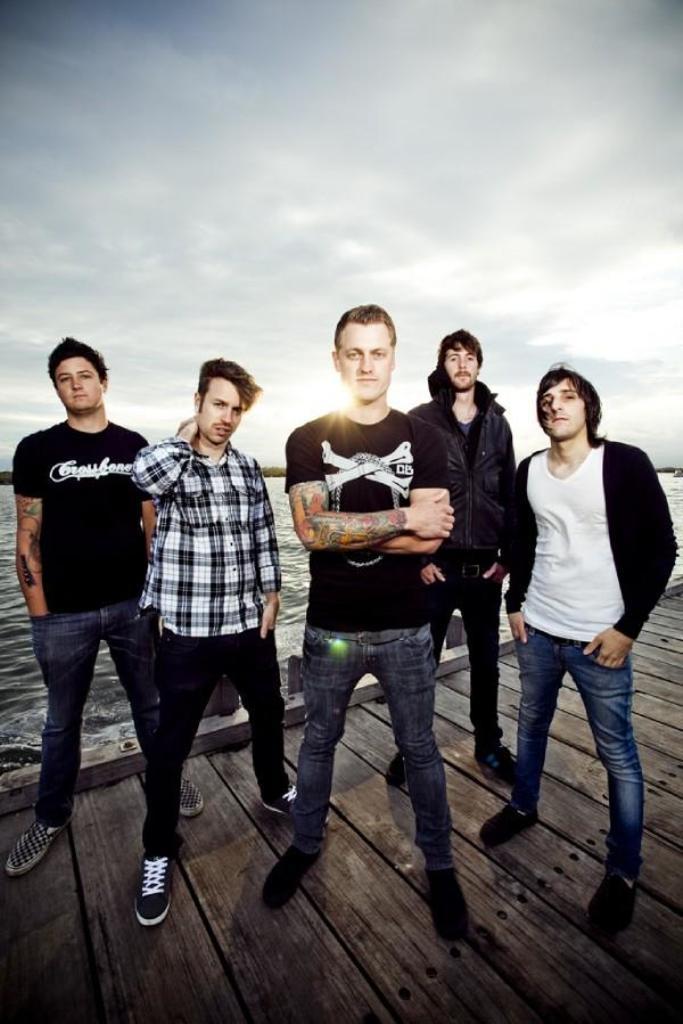Please provide a concise description of this image. In this picture we can see a group of people standing on a wooden platform and in the background we can see water, sky. 